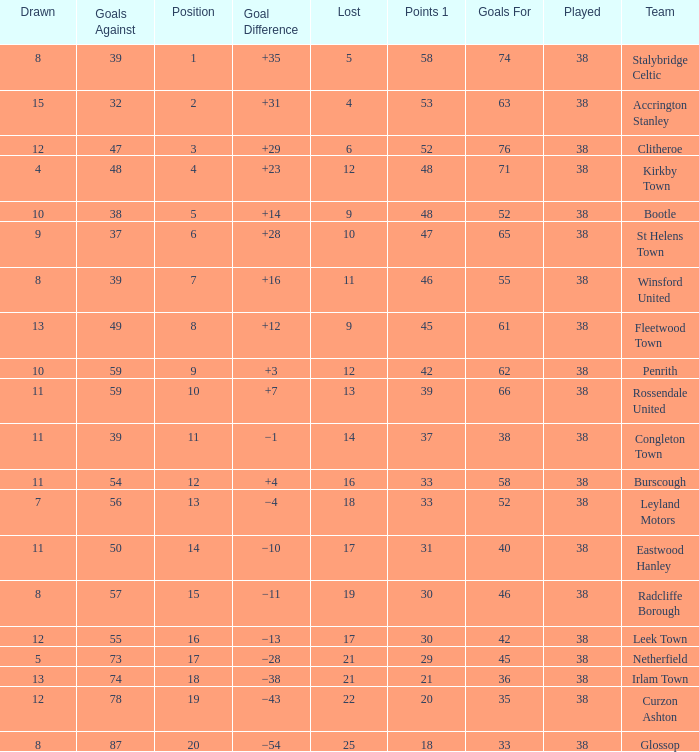What is the total number of losses for a draw of 7, and 1 points less than 33? 0.0. 